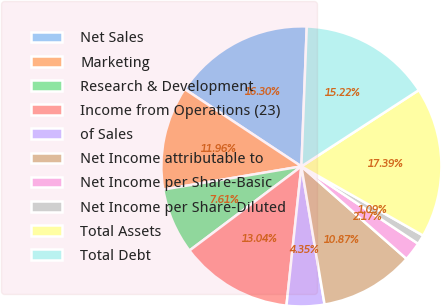Convert chart. <chart><loc_0><loc_0><loc_500><loc_500><pie_chart><fcel>Net Sales<fcel>Marketing<fcel>Research & Development<fcel>Income from Operations (23)<fcel>of Sales<fcel>Net Income attributable to<fcel>Net Income per Share-Basic<fcel>Net Income per Share-Diluted<fcel>Total Assets<fcel>Total Debt<nl><fcel>16.3%<fcel>11.96%<fcel>7.61%<fcel>13.04%<fcel>4.35%<fcel>10.87%<fcel>2.17%<fcel>1.09%<fcel>17.39%<fcel>15.22%<nl></chart> 